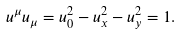<formula> <loc_0><loc_0><loc_500><loc_500>u ^ { \mu } u _ { \mu } = u _ { 0 } ^ { 2 } - u _ { x } ^ { 2 } - u _ { y } ^ { 2 } = 1 .</formula> 